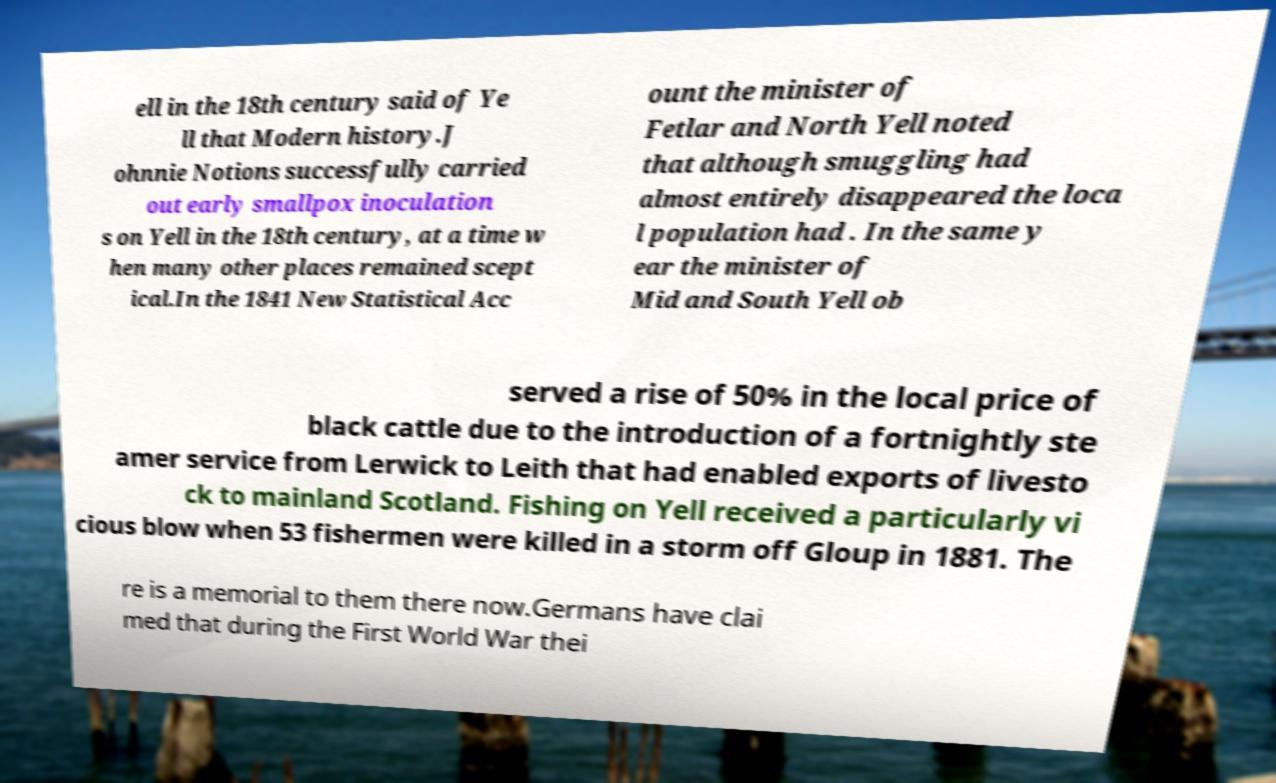Can you accurately transcribe the text from the provided image for me? ell in the 18th century said of Ye ll that Modern history.J ohnnie Notions successfully carried out early smallpox inoculation s on Yell in the 18th century, at a time w hen many other places remained scept ical.In the 1841 New Statistical Acc ount the minister of Fetlar and North Yell noted that although smuggling had almost entirely disappeared the loca l population had . In the same y ear the minister of Mid and South Yell ob served a rise of 50% in the local price of black cattle due to the introduction of a fortnightly ste amer service from Lerwick to Leith that had enabled exports of livesto ck to mainland Scotland. Fishing on Yell received a particularly vi cious blow when 53 fishermen were killed in a storm off Gloup in 1881. The re is a memorial to them there now.Germans have clai med that during the First World War thei 